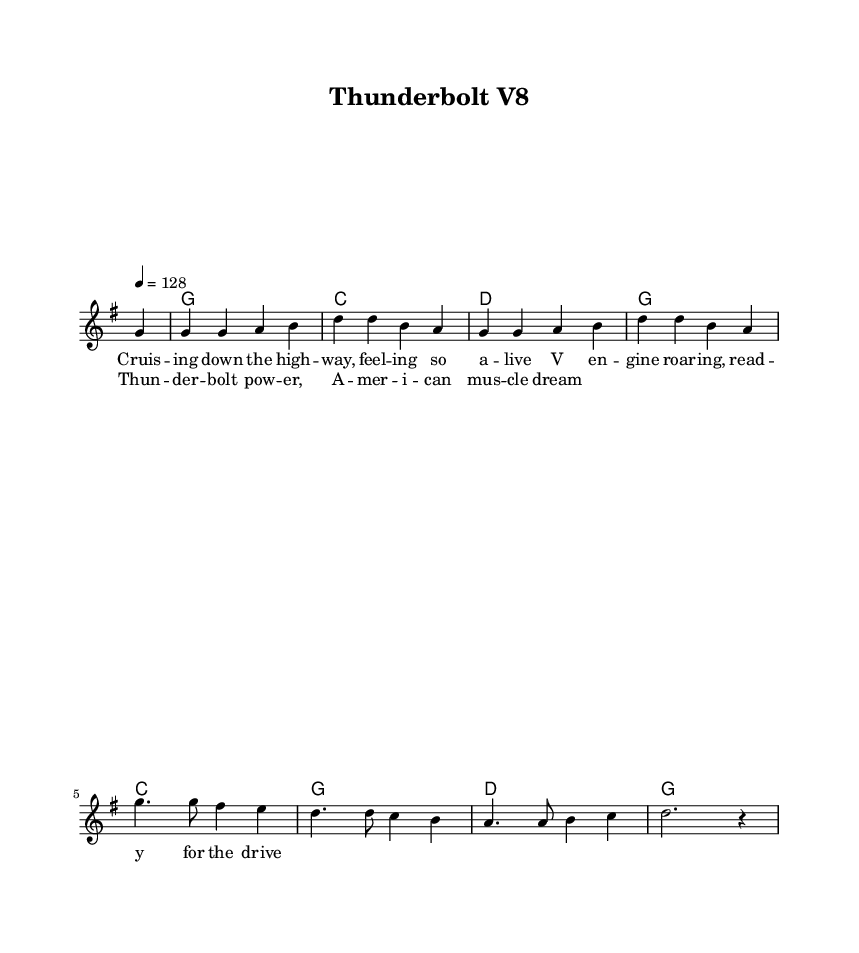What is the key signature of this music? The key signature is G major, indicated by one sharp (F#) in the key signature section.
Answer: G major What is the time signature of the piece? The time signature displayed in the sheet music is 4/4, which indicates four beats per measure.
Answer: 4/4 What is the tempo marking for the piece? The tempo is marked as quarter note equals 128 beats per minute, which indicates the speed at which the music should be played.
Answer: 128 How many measures are in the melody section? Counting the measures in the melody, there are a total of eight measures present.
Answer: Eight What is the main lyrical theme of the song? The song revolves around the theme of cruising in a car and the power of a V8 engine, aligning with the country rock genre's focus on automobiles.
Answer: Cruising and V8 engine What chord follows the G major chord in the harmonies? The chord that follows the G major chord in the harmonies is C major, observed in the chord progression after the first G major.
Answer: C major What is the overall mood suggested by the lyrics and music style? The lyrics and upbeat nature of the melody suggest a lively and adventurous mood, typical of country rock anthems that celebrate freedom and driving.
Answer: Lively and adventurous 